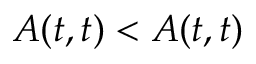<formula> <loc_0><loc_0><loc_500><loc_500>A ( t , t ) < A ( t , t )</formula> 